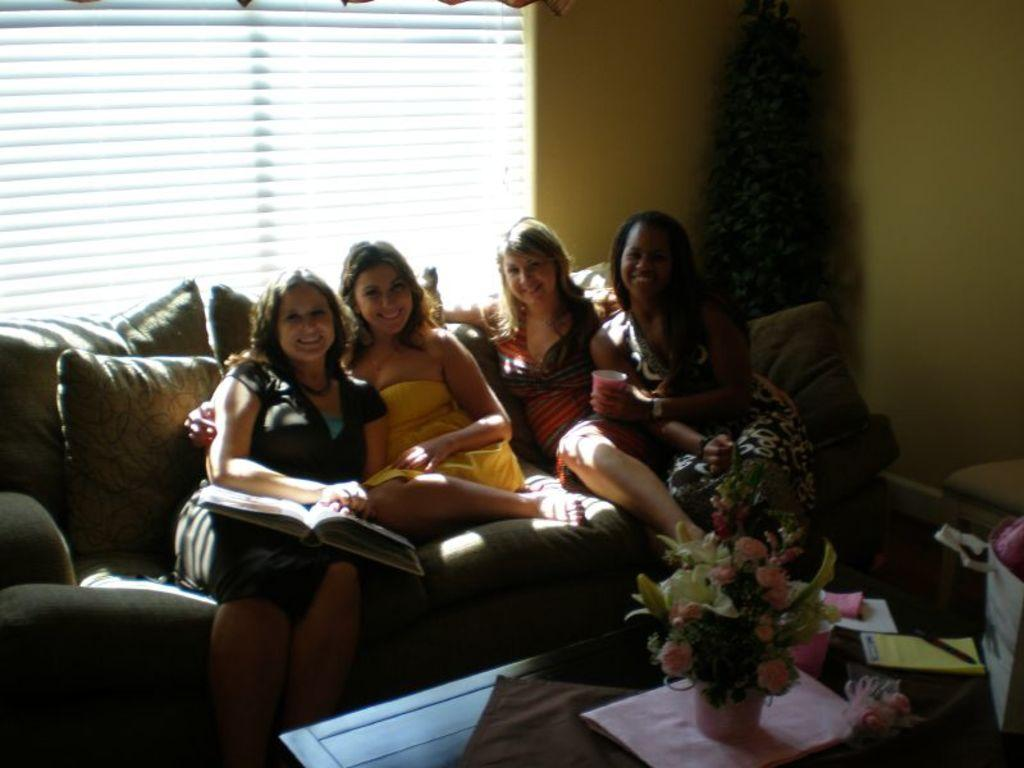What is the main subject of the image? The main subject of the image is a group of women. What are the women doing in the image? The women are sitting on a couch and smiling. What is present in front of the women? There is a table in front of the women. What can be seen on the table? There is a plant on the table. What can be seen in the background of the image? There are window flaps visible in the background. What type of fuel is being used by the moon in the image? There is no moon present in the image, and therefore no fuel can be associated with it. 